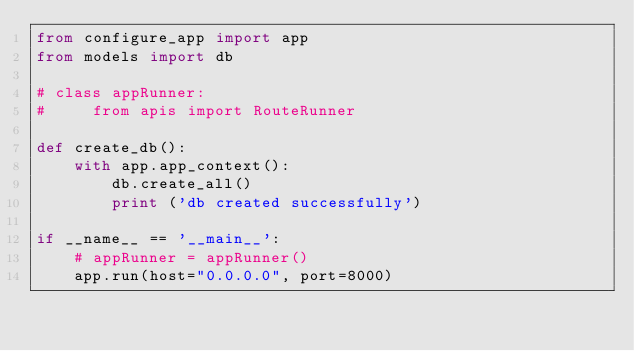<code> <loc_0><loc_0><loc_500><loc_500><_Python_>from configure_app import app
from models import db

# class appRunner:
#     from apis import RouteRunner

def create_db():
    with app.app_context(): 
        db.create_all()
        print ('db created successfully')

if __name__ == '__main__':
    # appRunner = appRunner()
    app.run(host="0.0.0.0", port=8000)</code> 